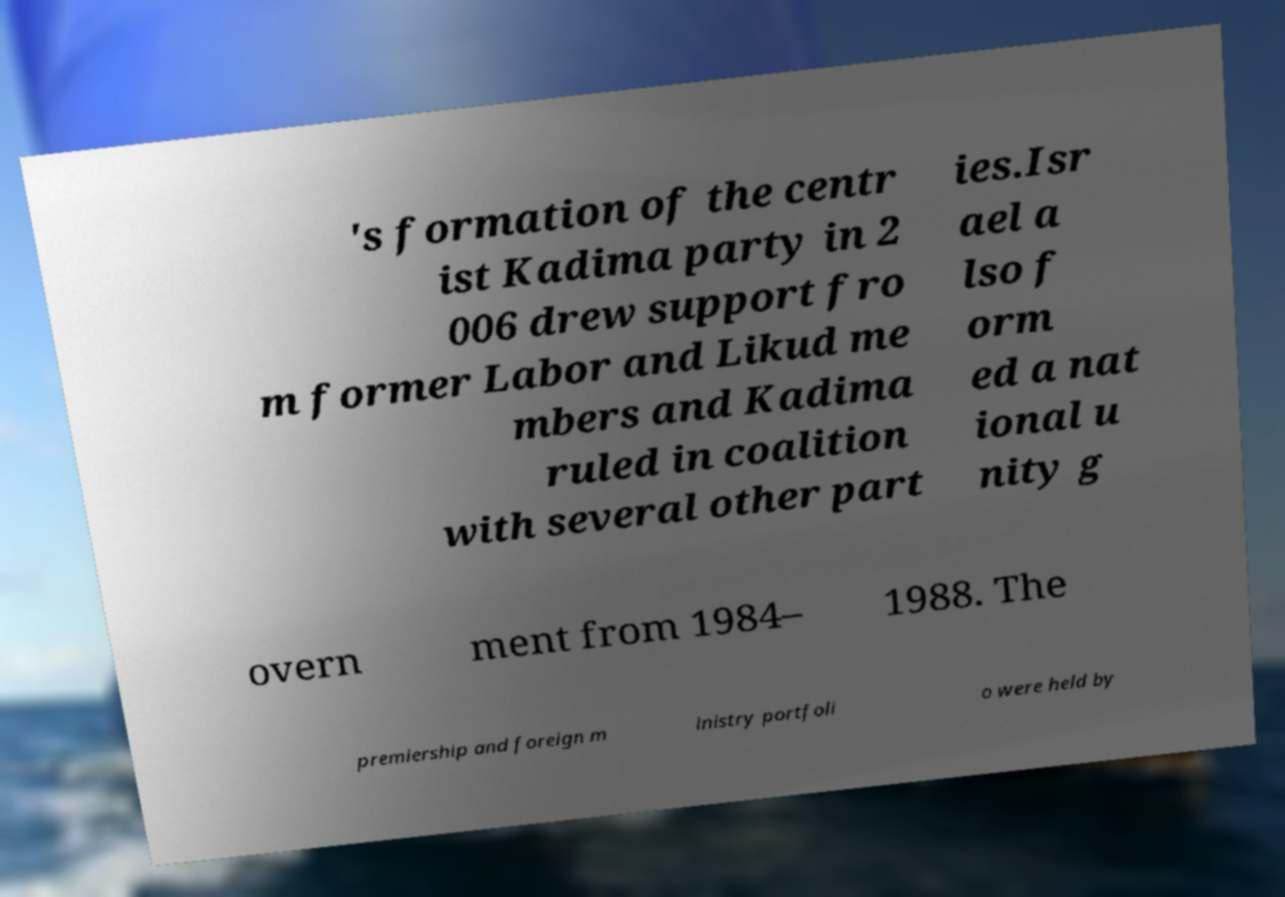Can you read and provide the text displayed in the image?This photo seems to have some interesting text. Can you extract and type it out for me? 's formation of the centr ist Kadima party in 2 006 drew support fro m former Labor and Likud me mbers and Kadima ruled in coalition with several other part ies.Isr ael a lso f orm ed a nat ional u nity g overn ment from 1984– 1988. The premiership and foreign m inistry portfoli o were held by 